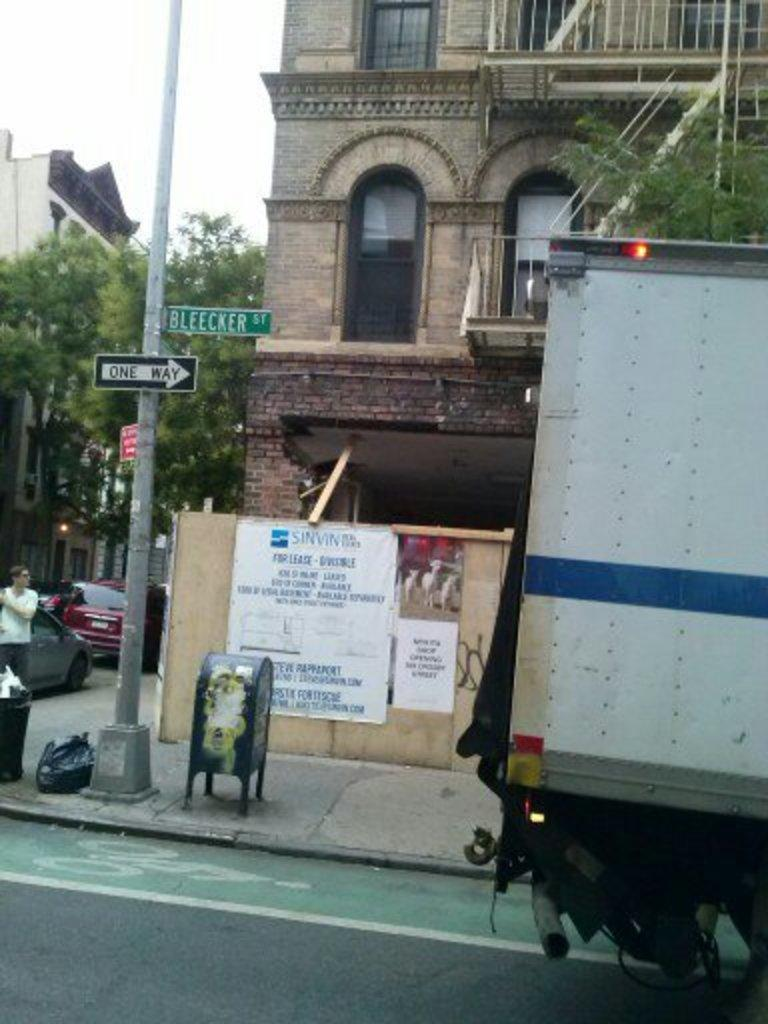What type of structures can be seen in the image? There are buildings in the image. Are there any living beings present in the image? Yes, there are people in the image. What mode of transportation is visible in the image? A vehicle is present in the image. What are the vertical structures in the image used for? There are poles in the image, which are likely used for support or signage. What type of signage or advertisements can be seen in the image? Posters are visible in the image. What else can be found on the ground in the image? There are other things on the ground in the image, but their specific nature is not mentioned in the provided facts. What type of cream is being used to extinguish the fire in the image? There is no fire present in the image, so there is no need for cream to extinguish it. What type of tent is set up in the image? There is no tent present in the image. 